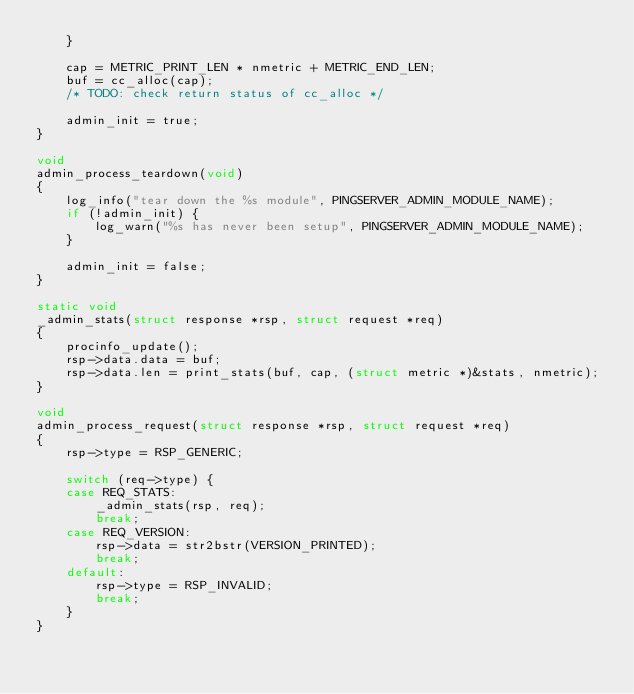Convert code to text. <code><loc_0><loc_0><loc_500><loc_500><_C_>    }

    cap = METRIC_PRINT_LEN * nmetric + METRIC_END_LEN;
    buf = cc_alloc(cap);
    /* TODO: check return status of cc_alloc */

    admin_init = true;
}

void
admin_process_teardown(void)
{
    log_info("tear down the %s module", PINGSERVER_ADMIN_MODULE_NAME);
    if (!admin_init) {
        log_warn("%s has never been setup", PINGSERVER_ADMIN_MODULE_NAME);
    }

    admin_init = false;
}

static void
_admin_stats(struct response *rsp, struct request *req)
{
    procinfo_update();
    rsp->data.data = buf;
    rsp->data.len = print_stats(buf, cap, (struct metric *)&stats, nmetric);
}

void
admin_process_request(struct response *rsp, struct request *req)
{
    rsp->type = RSP_GENERIC;

    switch (req->type) {
    case REQ_STATS:
        _admin_stats(rsp, req);
        break;
    case REQ_VERSION:
        rsp->data = str2bstr(VERSION_PRINTED);
        break;
    default:
        rsp->type = RSP_INVALID;
        break;
    }
}
</code> 